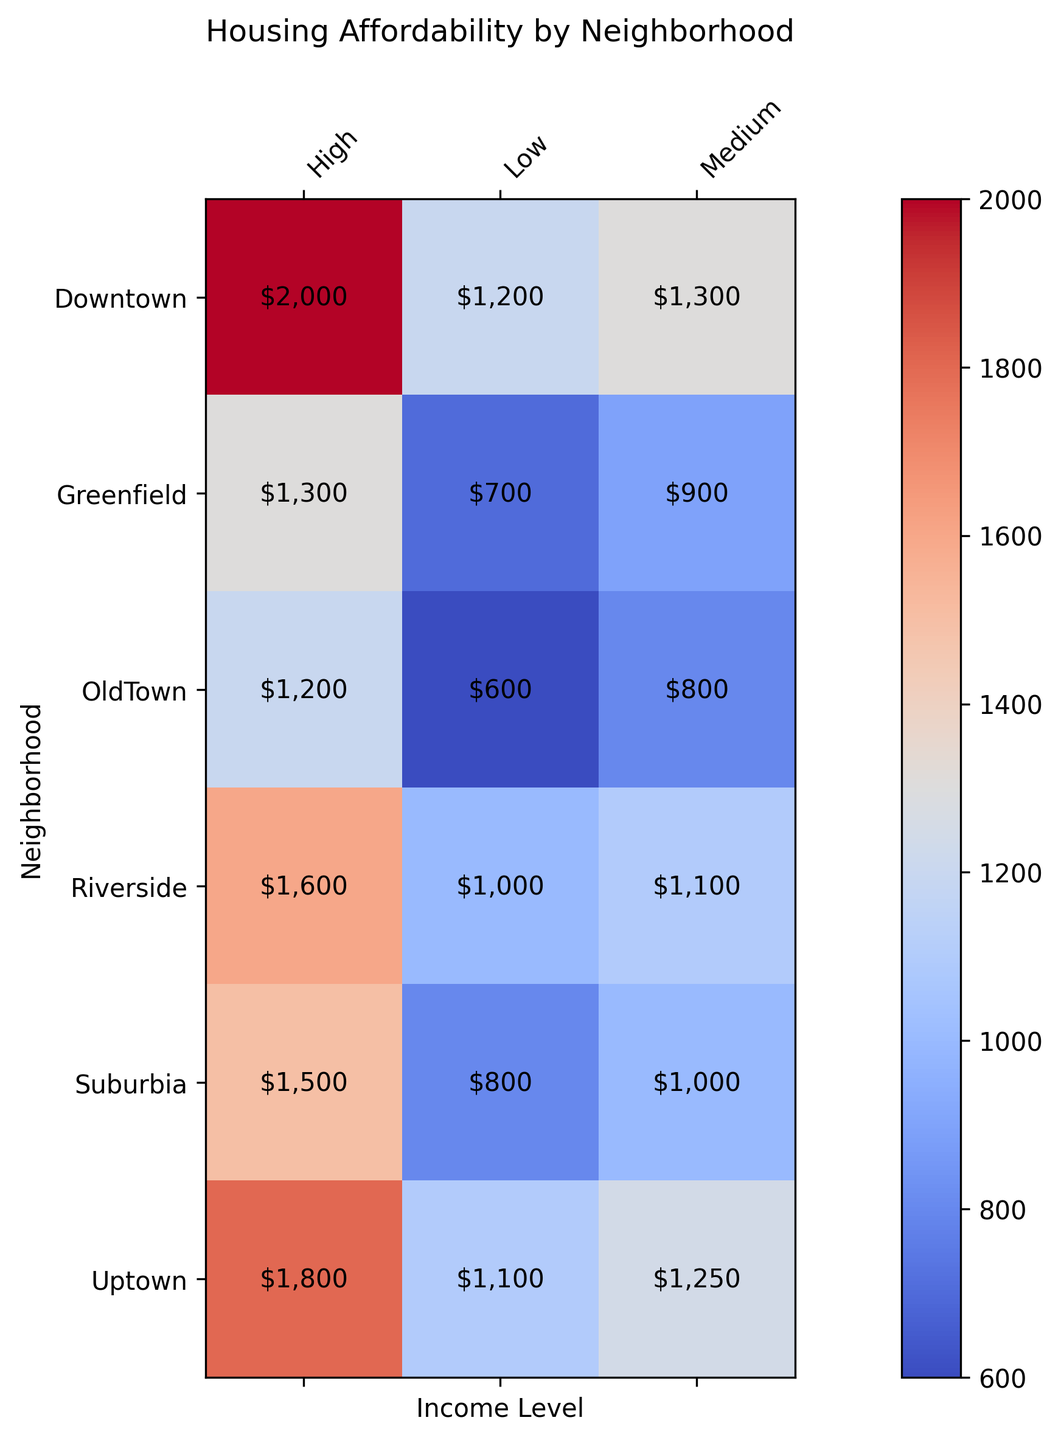What is the median rent for the 'Medium' income level in 'Suburbia'? Locate the 'Suburbia' row and the 'Medium' income level column in the heatmap. The intersection shows the median rent.
Answer: $1000 Which neighborhood has the highest median rent for 'High' income level? Compare the values in the 'High' income level column for each neighborhood. The highest value determines the neighborhood with the highest median rent.
Answer: Downtown What is the average median rent for the 'Low' income level across all neighborhoods? Sum the 'Low' income level median rents for all neighborhoods: 1200 (Downtown) + 800 (Suburbia) + 700 (Greenfield) + 1000 (Riverside) + 600 (OldTown) + 1100 (Uptown) = 5400. Then, divide by the number of neighborhoods: 5400 / 6.
Answer: $900 Which income level shows the most variation in median rents across neighborhoods? Identify the range of median rents (difference between highest and lowest values) for each income level column. The column with the largest range shows the most variation. 'Low' ranges from $600 to $1200, 'Medium' from $800 to $1300, 'High' from $1200 to $2000.
Answer: High Is there a neighborhood with a consistent increase in median rent as income level rises? Examine each neighborhood row to see if the median rent increases consistently from 'Low' to 'Medium' to 'High' income levels. Downtown, Riverside, Uptown all show consistent increases.
Answer: Yes Compare the median rent for 'Greenfield' and 'OldTown' neighborhoods at the 'High' income level. Which has a lower rent? Locate the 'High' income level column and compare the median rent values for 'Greenfield' and 'OldTown'. Greenfield: $1300, OldTown: $1200.
Answer: OldTown What is the difference in median rent between 'Downtown' and 'Uptown' for the 'Medium' income level? Subtract the median rent for 'Medium' income level in Uptown from that in Downtown. Downtown: $1300, Uptown: $1250. Difference: $1300 - $1250.
Answer: $50 Which neighborhood has the lowest median rent for the 'Medium' income level? Compare the values in the 'Medium' income level column for each neighborhood. The smallest value determines the neighborhood with the lowest median rent.
Answer: OldTown 